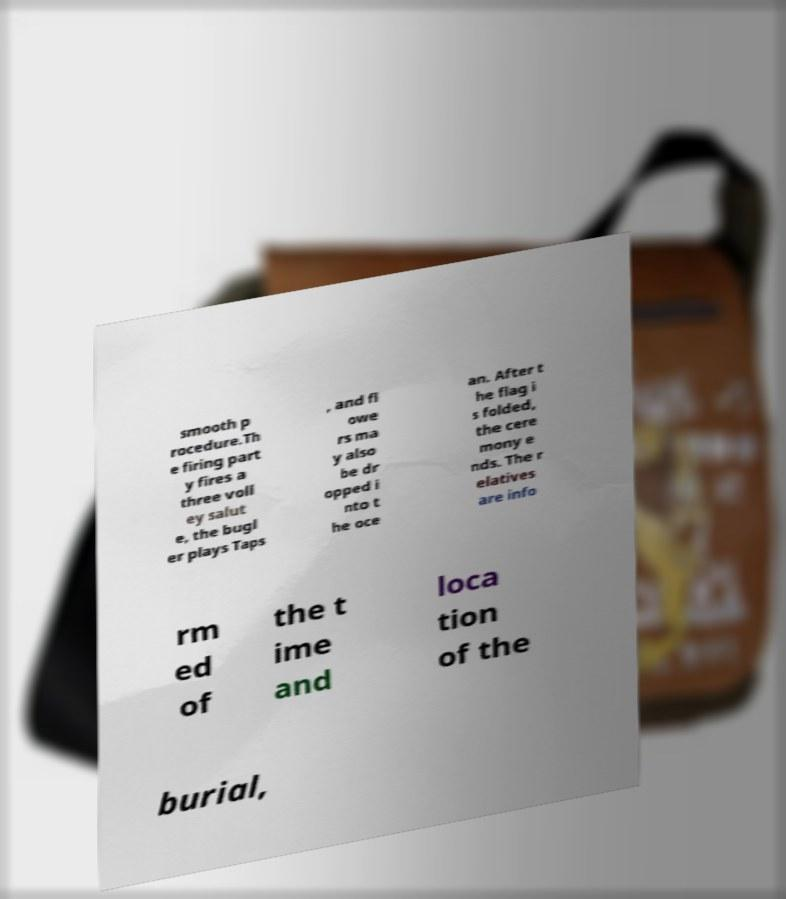Please identify and transcribe the text found in this image. smooth p rocedure.Th e firing part y fires a three voll ey salut e, the bugl er plays Taps , and fl owe rs ma y also be dr opped i nto t he oce an. After t he flag i s folded, the cere mony e nds. The r elatives are info rm ed of the t ime and loca tion of the burial, 